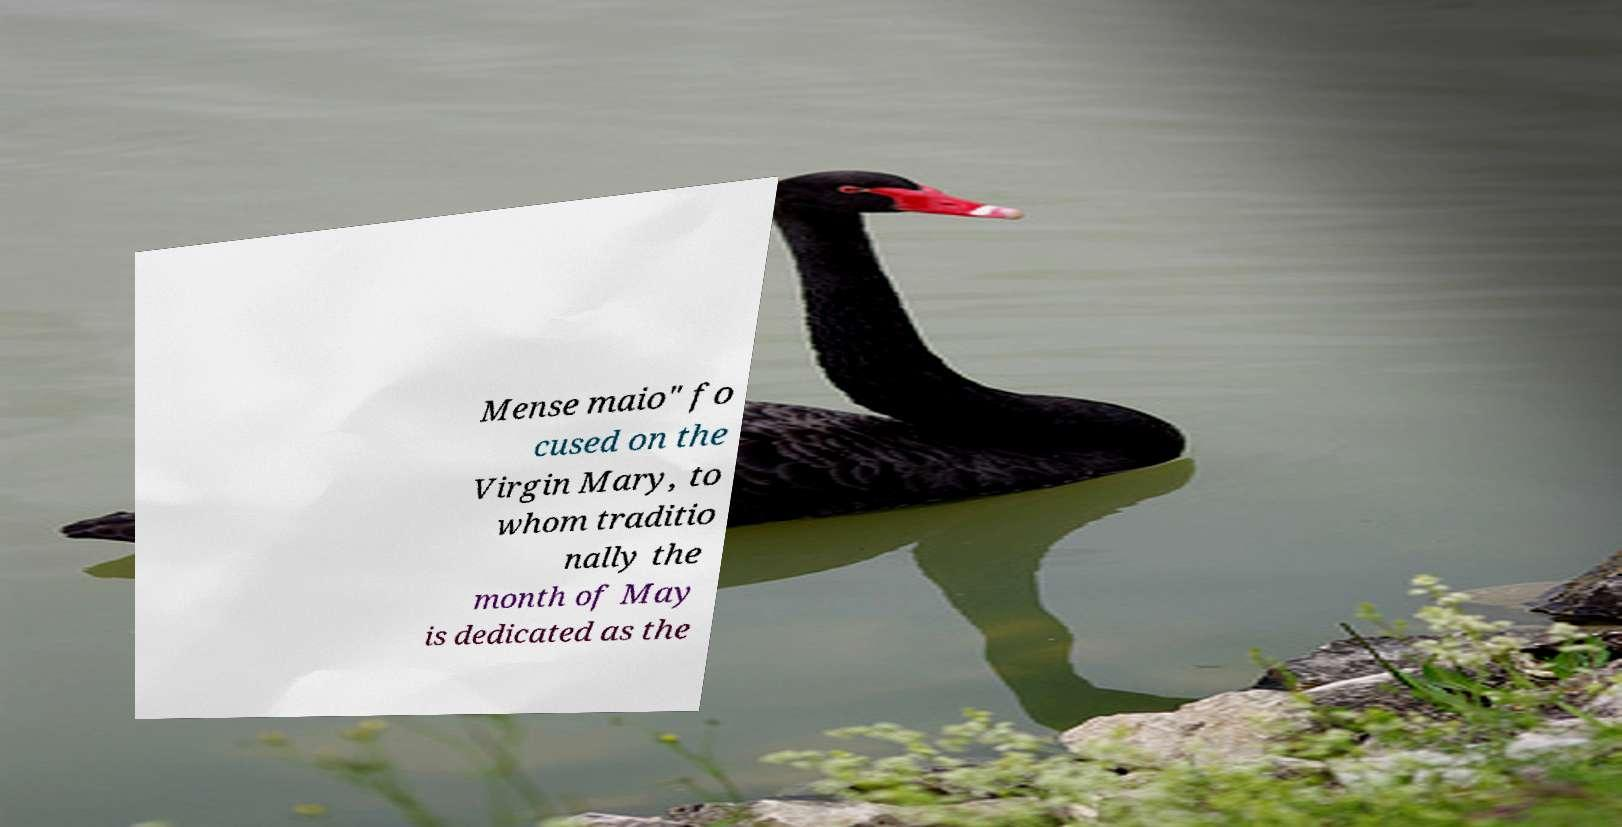What messages or text are displayed in this image? I need them in a readable, typed format. Mense maio" fo cused on the Virgin Mary, to whom traditio nally the month of May is dedicated as the 